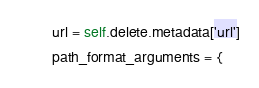<code> <loc_0><loc_0><loc_500><loc_500><_Python_>        url = self.delete.metadata['url']
        path_format_arguments = {</code> 